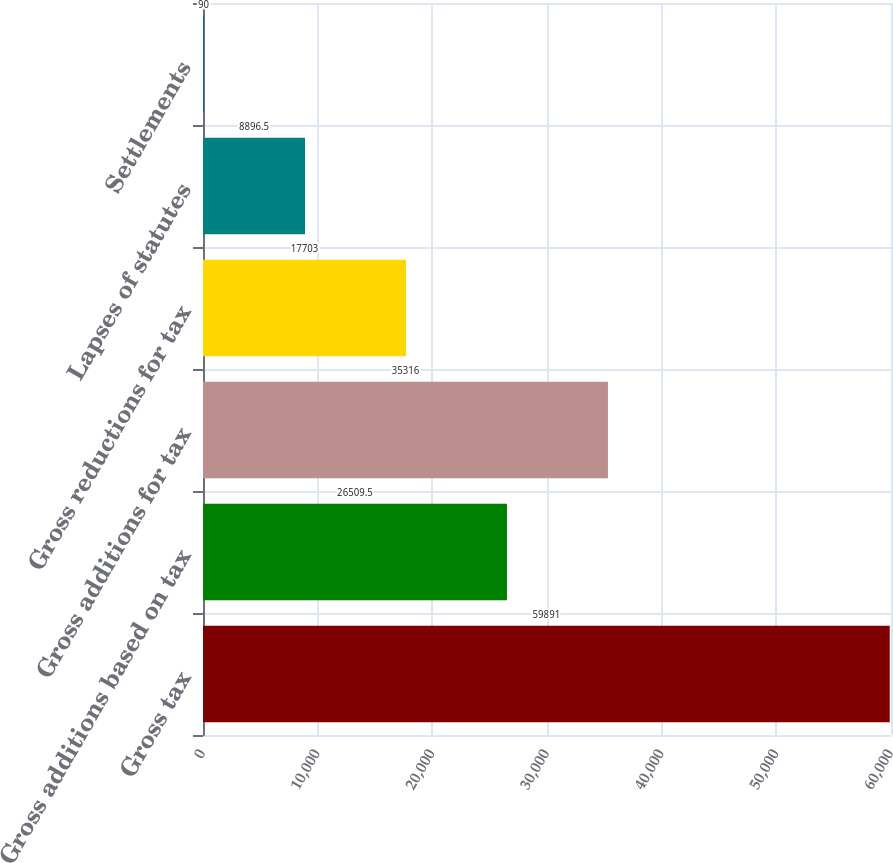<chart> <loc_0><loc_0><loc_500><loc_500><bar_chart><fcel>Gross tax<fcel>Gross additions based on tax<fcel>Gross additions for tax<fcel>Gross reductions for tax<fcel>Lapses of statutes<fcel>Settlements<nl><fcel>59891<fcel>26509.5<fcel>35316<fcel>17703<fcel>8896.5<fcel>90<nl></chart> 